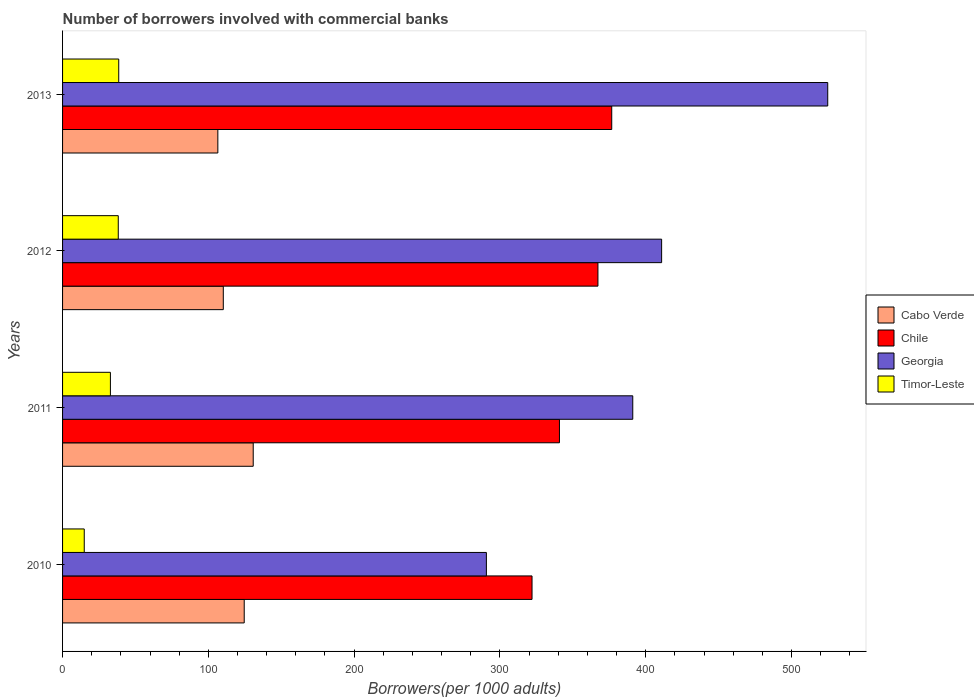Are the number of bars on each tick of the Y-axis equal?
Offer a very short reply. Yes. How many bars are there on the 3rd tick from the top?
Ensure brevity in your answer.  4. How many bars are there on the 3rd tick from the bottom?
Offer a very short reply. 4. What is the number of borrowers involved with commercial banks in Timor-Leste in 2010?
Ensure brevity in your answer.  14.87. Across all years, what is the maximum number of borrowers involved with commercial banks in Cabo Verde?
Give a very brief answer. 130.78. Across all years, what is the minimum number of borrowers involved with commercial banks in Timor-Leste?
Offer a very short reply. 14.87. What is the total number of borrowers involved with commercial banks in Cabo Verde in the graph?
Ensure brevity in your answer.  472.15. What is the difference between the number of borrowers involved with commercial banks in Cabo Verde in 2010 and that in 2013?
Your answer should be very brief. 18.1. What is the difference between the number of borrowers involved with commercial banks in Timor-Leste in 2010 and the number of borrowers involved with commercial banks in Cabo Verde in 2012?
Keep it short and to the point. -95.38. What is the average number of borrowers involved with commercial banks in Georgia per year?
Make the answer very short. 404.41. In the year 2010, what is the difference between the number of borrowers involved with commercial banks in Timor-Leste and number of borrowers involved with commercial banks in Chile?
Provide a succinct answer. -307.16. What is the ratio of the number of borrowers involved with commercial banks in Georgia in 2010 to that in 2011?
Provide a succinct answer. 0.74. Is the number of borrowers involved with commercial banks in Chile in 2010 less than that in 2013?
Ensure brevity in your answer.  Yes. Is the difference between the number of borrowers involved with commercial banks in Timor-Leste in 2010 and 2013 greater than the difference between the number of borrowers involved with commercial banks in Chile in 2010 and 2013?
Your response must be concise. Yes. What is the difference between the highest and the second highest number of borrowers involved with commercial banks in Chile?
Your response must be concise. 9.46. What is the difference between the highest and the lowest number of borrowers involved with commercial banks in Georgia?
Your response must be concise. 234.14. In how many years, is the number of borrowers involved with commercial banks in Georgia greater than the average number of borrowers involved with commercial banks in Georgia taken over all years?
Your answer should be compact. 2. Is the sum of the number of borrowers involved with commercial banks in Timor-Leste in 2011 and 2012 greater than the maximum number of borrowers involved with commercial banks in Chile across all years?
Offer a very short reply. No. Is it the case that in every year, the sum of the number of borrowers involved with commercial banks in Timor-Leste and number of borrowers involved with commercial banks in Chile is greater than the sum of number of borrowers involved with commercial banks in Georgia and number of borrowers involved with commercial banks in Cabo Verde?
Your answer should be compact. No. What does the 3rd bar from the top in 2012 represents?
Your answer should be compact. Chile. What does the 3rd bar from the bottom in 2013 represents?
Provide a succinct answer. Georgia. Is it the case that in every year, the sum of the number of borrowers involved with commercial banks in Cabo Verde and number of borrowers involved with commercial banks in Chile is greater than the number of borrowers involved with commercial banks in Georgia?
Provide a short and direct response. No. How many years are there in the graph?
Provide a succinct answer. 4. What is the difference between two consecutive major ticks on the X-axis?
Make the answer very short. 100. Are the values on the major ticks of X-axis written in scientific E-notation?
Offer a terse response. No. Does the graph contain any zero values?
Make the answer very short. No. Does the graph contain grids?
Keep it short and to the point. No. Where does the legend appear in the graph?
Your answer should be compact. Center right. How many legend labels are there?
Your answer should be very brief. 4. How are the legend labels stacked?
Keep it short and to the point. Vertical. What is the title of the graph?
Provide a succinct answer. Number of borrowers involved with commercial banks. What is the label or title of the X-axis?
Make the answer very short. Borrowers(per 1000 adults). What is the label or title of the Y-axis?
Offer a very short reply. Years. What is the Borrowers(per 1000 adults) in Cabo Verde in 2010?
Your response must be concise. 124.61. What is the Borrowers(per 1000 adults) of Chile in 2010?
Make the answer very short. 322.03. What is the Borrowers(per 1000 adults) in Georgia in 2010?
Ensure brevity in your answer.  290.72. What is the Borrowers(per 1000 adults) in Timor-Leste in 2010?
Keep it short and to the point. 14.87. What is the Borrowers(per 1000 adults) of Cabo Verde in 2011?
Make the answer very short. 130.78. What is the Borrowers(per 1000 adults) in Chile in 2011?
Your response must be concise. 340.83. What is the Borrowers(per 1000 adults) of Georgia in 2011?
Provide a short and direct response. 391.13. What is the Borrowers(per 1000 adults) of Timor-Leste in 2011?
Ensure brevity in your answer.  32.81. What is the Borrowers(per 1000 adults) in Cabo Verde in 2012?
Offer a very short reply. 110.25. What is the Borrowers(per 1000 adults) of Chile in 2012?
Offer a very short reply. 367.24. What is the Borrowers(per 1000 adults) of Georgia in 2012?
Your answer should be very brief. 410.92. What is the Borrowers(per 1000 adults) in Timor-Leste in 2012?
Offer a terse response. 38.21. What is the Borrowers(per 1000 adults) in Cabo Verde in 2013?
Offer a terse response. 106.51. What is the Borrowers(per 1000 adults) in Chile in 2013?
Keep it short and to the point. 376.7. What is the Borrowers(per 1000 adults) in Georgia in 2013?
Offer a terse response. 524.86. What is the Borrowers(per 1000 adults) of Timor-Leste in 2013?
Offer a very short reply. 38.53. Across all years, what is the maximum Borrowers(per 1000 adults) in Cabo Verde?
Keep it short and to the point. 130.78. Across all years, what is the maximum Borrowers(per 1000 adults) of Chile?
Give a very brief answer. 376.7. Across all years, what is the maximum Borrowers(per 1000 adults) in Georgia?
Make the answer very short. 524.86. Across all years, what is the maximum Borrowers(per 1000 adults) of Timor-Leste?
Offer a terse response. 38.53. Across all years, what is the minimum Borrowers(per 1000 adults) of Cabo Verde?
Provide a succinct answer. 106.51. Across all years, what is the minimum Borrowers(per 1000 adults) of Chile?
Your answer should be compact. 322.03. Across all years, what is the minimum Borrowers(per 1000 adults) of Georgia?
Make the answer very short. 290.72. Across all years, what is the minimum Borrowers(per 1000 adults) in Timor-Leste?
Offer a very short reply. 14.87. What is the total Borrowers(per 1000 adults) in Cabo Verde in the graph?
Make the answer very short. 472.15. What is the total Borrowers(per 1000 adults) of Chile in the graph?
Provide a succinct answer. 1406.8. What is the total Borrowers(per 1000 adults) of Georgia in the graph?
Provide a succinct answer. 1617.64. What is the total Borrowers(per 1000 adults) of Timor-Leste in the graph?
Your response must be concise. 124.42. What is the difference between the Borrowers(per 1000 adults) in Cabo Verde in 2010 and that in 2011?
Provide a succinct answer. -6.18. What is the difference between the Borrowers(per 1000 adults) in Chile in 2010 and that in 2011?
Give a very brief answer. -18.8. What is the difference between the Borrowers(per 1000 adults) of Georgia in 2010 and that in 2011?
Your answer should be very brief. -100.4. What is the difference between the Borrowers(per 1000 adults) in Timor-Leste in 2010 and that in 2011?
Your answer should be very brief. -17.94. What is the difference between the Borrowers(per 1000 adults) of Cabo Verde in 2010 and that in 2012?
Offer a terse response. 14.36. What is the difference between the Borrowers(per 1000 adults) in Chile in 2010 and that in 2012?
Your response must be concise. -45.21. What is the difference between the Borrowers(per 1000 adults) of Georgia in 2010 and that in 2012?
Ensure brevity in your answer.  -120.2. What is the difference between the Borrowers(per 1000 adults) of Timor-Leste in 2010 and that in 2012?
Your answer should be compact. -23.34. What is the difference between the Borrowers(per 1000 adults) in Cabo Verde in 2010 and that in 2013?
Your answer should be very brief. 18.1. What is the difference between the Borrowers(per 1000 adults) in Chile in 2010 and that in 2013?
Give a very brief answer. -54.66. What is the difference between the Borrowers(per 1000 adults) of Georgia in 2010 and that in 2013?
Ensure brevity in your answer.  -234.14. What is the difference between the Borrowers(per 1000 adults) of Timor-Leste in 2010 and that in 2013?
Your answer should be compact. -23.66. What is the difference between the Borrowers(per 1000 adults) of Cabo Verde in 2011 and that in 2012?
Provide a short and direct response. 20.53. What is the difference between the Borrowers(per 1000 adults) in Chile in 2011 and that in 2012?
Offer a terse response. -26.41. What is the difference between the Borrowers(per 1000 adults) of Georgia in 2011 and that in 2012?
Offer a terse response. -19.79. What is the difference between the Borrowers(per 1000 adults) in Timor-Leste in 2011 and that in 2012?
Make the answer very short. -5.4. What is the difference between the Borrowers(per 1000 adults) in Cabo Verde in 2011 and that in 2013?
Your answer should be very brief. 24.27. What is the difference between the Borrowers(per 1000 adults) of Chile in 2011 and that in 2013?
Your answer should be very brief. -35.86. What is the difference between the Borrowers(per 1000 adults) of Georgia in 2011 and that in 2013?
Offer a very short reply. -133.74. What is the difference between the Borrowers(per 1000 adults) in Timor-Leste in 2011 and that in 2013?
Give a very brief answer. -5.72. What is the difference between the Borrowers(per 1000 adults) in Cabo Verde in 2012 and that in 2013?
Give a very brief answer. 3.74. What is the difference between the Borrowers(per 1000 adults) of Chile in 2012 and that in 2013?
Offer a very short reply. -9.46. What is the difference between the Borrowers(per 1000 adults) in Georgia in 2012 and that in 2013?
Make the answer very short. -113.94. What is the difference between the Borrowers(per 1000 adults) in Timor-Leste in 2012 and that in 2013?
Give a very brief answer. -0.32. What is the difference between the Borrowers(per 1000 adults) in Cabo Verde in 2010 and the Borrowers(per 1000 adults) in Chile in 2011?
Offer a very short reply. -216.23. What is the difference between the Borrowers(per 1000 adults) in Cabo Verde in 2010 and the Borrowers(per 1000 adults) in Georgia in 2011?
Ensure brevity in your answer.  -266.52. What is the difference between the Borrowers(per 1000 adults) of Cabo Verde in 2010 and the Borrowers(per 1000 adults) of Timor-Leste in 2011?
Your response must be concise. 91.8. What is the difference between the Borrowers(per 1000 adults) of Chile in 2010 and the Borrowers(per 1000 adults) of Georgia in 2011?
Your answer should be very brief. -69.1. What is the difference between the Borrowers(per 1000 adults) of Chile in 2010 and the Borrowers(per 1000 adults) of Timor-Leste in 2011?
Provide a short and direct response. 289.22. What is the difference between the Borrowers(per 1000 adults) of Georgia in 2010 and the Borrowers(per 1000 adults) of Timor-Leste in 2011?
Your answer should be compact. 257.91. What is the difference between the Borrowers(per 1000 adults) in Cabo Verde in 2010 and the Borrowers(per 1000 adults) in Chile in 2012?
Provide a short and direct response. -242.63. What is the difference between the Borrowers(per 1000 adults) of Cabo Verde in 2010 and the Borrowers(per 1000 adults) of Georgia in 2012?
Ensure brevity in your answer.  -286.31. What is the difference between the Borrowers(per 1000 adults) in Cabo Verde in 2010 and the Borrowers(per 1000 adults) in Timor-Leste in 2012?
Your response must be concise. 86.4. What is the difference between the Borrowers(per 1000 adults) in Chile in 2010 and the Borrowers(per 1000 adults) in Georgia in 2012?
Your answer should be compact. -88.89. What is the difference between the Borrowers(per 1000 adults) of Chile in 2010 and the Borrowers(per 1000 adults) of Timor-Leste in 2012?
Keep it short and to the point. 283.82. What is the difference between the Borrowers(per 1000 adults) in Georgia in 2010 and the Borrowers(per 1000 adults) in Timor-Leste in 2012?
Keep it short and to the point. 252.51. What is the difference between the Borrowers(per 1000 adults) in Cabo Verde in 2010 and the Borrowers(per 1000 adults) in Chile in 2013?
Offer a terse response. -252.09. What is the difference between the Borrowers(per 1000 adults) of Cabo Verde in 2010 and the Borrowers(per 1000 adults) of Georgia in 2013?
Make the answer very short. -400.26. What is the difference between the Borrowers(per 1000 adults) in Cabo Verde in 2010 and the Borrowers(per 1000 adults) in Timor-Leste in 2013?
Your answer should be very brief. 86.07. What is the difference between the Borrowers(per 1000 adults) in Chile in 2010 and the Borrowers(per 1000 adults) in Georgia in 2013?
Ensure brevity in your answer.  -202.83. What is the difference between the Borrowers(per 1000 adults) of Chile in 2010 and the Borrowers(per 1000 adults) of Timor-Leste in 2013?
Offer a terse response. 283.5. What is the difference between the Borrowers(per 1000 adults) in Georgia in 2010 and the Borrowers(per 1000 adults) in Timor-Leste in 2013?
Your response must be concise. 252.19. What is the difference between the Borrowers(per 1000 adults) of Cabo Verde in 2011 and the Borrowers(per 1000 adults) of Chile in 2012?
Your answer should be compact. -236.46. What is the difference between the Borrowers(per 1000 adults) of Cabo Verde in 2011 and the Borrowers(per 1000 adults) of Georgia in 2012?
Your response must be concise. -280.14. What is the difference between the Borrowers(per 1000 adults) in Cabo Verde in 2011 and the Borrowers(per 1000 adults) in Timor-Leste in 2012?
Provide a succinct answer. 92.57. What is the difference between the Borrowers(per 1000 adults) of Chile in 2011 and the Borrowers(per 1000 adults) of Georgia in 2012?
Provide a short and direct response. -70.09. What is the difference between the Borrowers(per 1000 adults) of Chile in 2011 and the Borrowers(per 1000 adults) of Timor-Leste in 2012?
Your answer should be very brief. 302.62. What is the difference between the Borrowers(per 1000 adults) of Georgia in 2011 and the Borrowers(per 1000 adults) of Timor-Leste in 2012?
Provide a succinct answer. 352.92. What is the difference between the Borrowers(per 1000 adults) in Cabo Verde in 2011 and the Borrowers(per 1000 adults) in Chile in 2013?
Keep it short and to the point. -245.91. What is the difference between the Borrowers(per 1000 adults) of Cabo Verde in 2011 and the Borrowers(per 1000 adults) of Georgia in 2013?
Offer a terse response. -394.08. What is the difference between the Borrowers(per 1000 adults) in Cabo Verde in 2011 and the Borrowers(per 1000 adults) in Timor-Leste in 2013?
Provide a short and direct response. 92.25. What is the difference between the Borrowers(per 1000 adults) of Chile in 2011 and the Borrowers(per 1000 adults) of Georgia in 2013?
Your response must be concise. -184.03. What is the difference between the Borrowers(per 1000 adults) of Chile in 2011 and the Borrowers(per 1000 adults) of Timor-Leste in 2013?
Ensure brevity in your answer.  302.3. What is the difference between the Borrowers(per 1000 adults) of Georgia in 2011 and the Borrowers(per 1000 adults) of Timor-Leste in 2013?
Provide a succinct answer. 352.59. What is the difference between the Borrowers(per 1000 adults) of Cabo Verde in 2012 and the Borrowers(per 1000 adults) of Chile in 2013?
Your answer should be very brief. -266.45. What is the difference between the Borrowers(per 1000 adults) in Cabo Verde in 2012 and the Borrowers(per 1000 adults) in Georgia in 2013?
Offer a very short reply. -414.61. What is the difference between the Borrowers(per 1000 adults) in Cabo Verde in 2012 and the Borrowers(per 1000 adults) in Timor-Leste in 2013?
Your answer should be compact. 71.72. What is the difference between the Borrowers(per 1000 adults) in Chile in 2012 and the Borrowers(per 1000 adults) in Georgia in 2013?
Offer a very short reply. -157.63. What is the difference between the Borrowers(per 1000 adults) in Chile in 2012 and the Borrowers(per 1000 adults) in Timor-Leste in 2013?
Ensure brevity in your answer.  328.7. What is the difference between the Borrowers(per 1000 adults) of Georgia in 2012 and the Borrowers(per 1000 adults) of Timor-Leste in 2013?
Ensure brevity in your answer.  372.39. What is the average Borrowers(per 1000 adults) of Cabo Verde per year?
Your answer should be compact. 118.04. What is the average Borrowers(per 1000 adults) of Chile per year?
Your response must be concise. 351.7. What is the average Borrowers(per 1000 adults) of Georgia per year?
Give a very brief answer. 404.41. What is the average Borrowers(per 1000 adults) of Timor-Leste per year?
Your answer should be very brief. 31.11. In the year 2010, what is the difference between the Borrowers(per 1000 adults) of Cabo Verde and Borrowers(per 1000 adults) of Chile?
Your response must be concise. -197.42. In the year 2010, what is the difference between the Borrowers(per 1000 adults) in Cabo Verde and Borrowers(per 1000 adults) in Georgia?
Offer a very short reply. -166.12. In the year 2010, what is the difference between the Borrowers(per 1000 adults) of Cabo Verde and Borrowers(per 1000 adults) of Timor-Leste?
Make the answer very short. 109.74. In the year 2010, what is the difference between the Borrowers(per 1000 adults) of Chile and Borrowers(per 1000 adults) of Georgia?
Give a very brief answer. 31.31. In the year 2010, what is the difference between the Borrowers(per 1000 adults) of Chile and Borrowers(per 1000 adults) of Timor-Leste?
Offer a terse response. 307.16. In the year 2010, what is the difference between the Borrowers(per 1000 adults) of Georgia and Borrowers(per 1000 adults) of Timor-Leste?
Your answer should be compact. 275.85. In the year 2011, what is the difference between the Borrowers(per 1000 adults) in Cabo Verde and Borrowers(per 1000 adults) in Chile?
Give a very brief answer. -210.05. In the year 2011, what is the difference between the Borrowers(per 1000 adults) in Cabo Verde and Borrowers(per 1000 adults) in Georgia?
Ensure brevity in your answer.  -260.34. In the year 2011, what is the difference between the Borrowers(per 1000 adults) of Cabo Verde and Borrowers(per 1000 adults) of Timor-Leste?
Provide a succinct answer. 97.97. In the year 2011, what is the difference between the Borrowers(per 1000 adults) in Chile and Borrowers(per 1000 adults) in Georgia?
Offer a very short reply. -50.29. In the year 2011, what is the difference between the Borrowers(per 1000 adults) in Chile and Borrowers(per 1000 adults) in Timor-Leste?
Give a very brief answer. 308.02. In the year 2011, what is the difference between the Borrowers(per 1000 adults) in Georgia and Borrowers(per 1000 adults) in Timor-Leste?
Your response must be concise. 358.32. In the year 2012, what is the difference between the Borrowers(per 1000 adults) in Cabo Verde and Borrowers(per 1000 adults) in Chile?
Your response must be concise. -256.99. In the year 2012, what is the difference between the Borrowers(per 1000 adults) of Cabo Verde and Borrowers(per 1000 adults) of Georgia?
Offer a very short reply. -300.67. In the year 2012, what is the difference between the Borrowers(per 1000 adults) of Cabo Verde and Borrowers(per 1000 adults) of Timor-Leste?
Ensure brevity in your answer.  72.04. In the year 2012, what is the difference between the Borrowers(per 1000 adults) in Chile and Borrowers(per 1000 adults) in Georgia?
Ensure brevity in your answer.  -43.68. In the year 2012, what is the difference between the Borrowers(per 1000 adults) in Chile and Borrowers(per 1000 adults) in Timor-Leste?
Ensure brevity in your answer.  329.03. In the year 2012, what is the difference between the Borrowers(per 1000 adults) in Georgia and Borrowers(per 1000 adults) in Timor-Leste?
Provide a succinct answer. 372.71. In the year 2013, what is the difference between the Borrowers(per 1000 adults) in Cabo Verde and Borrowers(per 1000 adults) in Chile?
Ensure brevity in your answer.  -270.19. In the year 2013, what is the difference between the Borrowers(per 1000 adults) in Cabo Verde and Borrowers(per 1000 adults) in Georgia?
Give a very brief answer. -418.36. In the year 2013, what is the difference between the Borrowers(per 1000 adults) in Cabo Verde and Borrowers(per 1000 adults) in Timor-Leste?
Ensure brevity in your answer.  67.97. In the year 2013, what is the difference between the Borrowers(per 1000 adults) of Chile and Borrowers(per 1000 adults) of Georgia?
Offer a very short reply. -148.17. In the year 2013, what is the difference between the Borrowers(per 1000 adults) in Chile and Borrowers(per 1000 adults) in Timor-Leste?
Your answer should be compact. 338.16. In the year 2013, what is the difference between the Borrowers(per 1000 adults) in Georgia and Borrowers(per 1000 adults) in Timor-Leste?
Your response must be concise. 486.33. What is the ratio of the Borrowers(per 1000 adults) of Cabo Verde in 2010 to that in 2011?
Provide a short and direct response. 0.95. What is the ratio of the Borrowers(per 1000 adults) of Chile in 2010 to that in 2011?
Ensure brevity in your answer.  0.94. What is the ratio of the Borrowers(per 1000 adults) of Georgia in 2010 to that in 2011?
Ensure brevity in your answer.  0.74. What is the ratio of the Borrowers(per 1000 adults) of Timor-Leste in 2010 to that in 2011?
Keep it short and to the point. 0.45. What is the ratio of the Borrowers(per 1000 adults) of Cabo Verde in 2010 to that in 2012?
Provide a succinct answer. 1.13. What is the ratio of the Borrowers(per 1000 adults) of Chile in 2010 to that in 2012?
Ensure brevity in your answer.  0.88. What is the ratio of the Borrowers(per 1000 adults) of Georgia in 2010 to that in 2012?
Keep it short and to the point. 0.71. What is the ratio of the Borrowers(per 1000 adults) of Timor-Leste in 2010 to that in 2012?
Provide a short and direct response. 0.39. What is the ratio of the Borrowers(per 1000 adults) in Cabo Verde in 2010 to that in 2013?
Your answer should be very brief. 1.17. What is the ratio of the Borrowers(per 1000 adults) in Chile in 2010 to that in 2013?
Give a very brief answer. 0.85. What is the ratio of the Borrowers(per 1000 adults) of Georgia in 2010 to that in 2013?
Your response must be concise. 0.55. What is the ratio of the Borrowers(per 1000 adults) in Timor-Leste in 2010 to that in 2013?
Offer a very short reply. 0.39. What is the ratio of the Borrowers(per 1000 adults) of Cabo Verde in 2011 to that in 2012?
Ensure brevity in your answer.  1.19. What is the ratio of the Borrowers(per 1000 adults) in Chile in 2011 to that in 2012?
Your answer should be compact. 0.93. What is the ratio of the Borrowers(per 1000 adults) of Georgia in 2011 to that in 2012?
Your response must be concise. 0.95. What is the ratio of the Borrowers(per 1000 adults) of Timor-Leste in 2011 to that in 2012?
Ensure brevity in your answer.  0.86. What is the ratio of the Borrowers(per 1000 adults) of Cabo Verde in 2011 to that in 2013?
Keep it short and to the point. 1.23. What is the ratio of the Borrowers(per 1000 adults) in Chile in 2011 to that in 2013?
Ensure brevity in your answer.  0.9. What is the ratio of the Borrowers(per 1000 adults) of Georgia in 2011 to that in 2013?
Your response must be concise. 0.75. What is the ratio of the Borrowers(per 1000 adults) of Timor-Leste in 2011 to that in 2013?
Your answer should be compact. 0.85. What is the ratio of the Borrowers(per 1000 adults) in Cabo Verde in 2012 to that in 2013?
Provide a succinct answer. 1.04. What is the ratio of the Borrowers(per 1000 adults) of Chile in 2012 to that in 2013?
Provide a short and direct response. 0.97. What is the ratio of the Borrowers(per 1000 adults) of Georgia in 2012 to that in 2013?
Give a very brief answer. 0.78. What is the ratio of the Borrowers(per 1000 adults) of Timor-Leste in 2012 to that in 2013?
Provide a short and direct response. 0.99. What is the difference between the highest and the second highest Borrowers(per 1000 adults) of Cabo Verde?
Give a very brief answer. 6.18. What is the difference between the highest and the second highest Borrowers(per 1000 adults) of Chile?
Offer a very short reply. 9.46. What is the difference between the highest and the second highest Borrowers(per 1000 adults) in Georgia?
Provide a short and direct response. 113.94. What is the difference between the highest and the second highest Borrowers(per 1000 adults) in Timor-Leste?
Give a very brief answer. 0.32. What is the difference between the highest and the lowest Borrowers(per 1000 adults) in Cabo Verde?
Give a very brief answer. 24.27. What is the difference between the highest and the lowest Borrowers(per 1000 adults) of Chile?
Give a very brief answer. 54.66. What is the difference between the highest and the lowest Borrowers(per 1000 adults) of Georgia?
Your answer should be compact. 234.14. What is the difference between the highest and the lowest Borrowers(per 1000 adults) in Timor-Leste?
Provide a short and direct response. 23.66. 